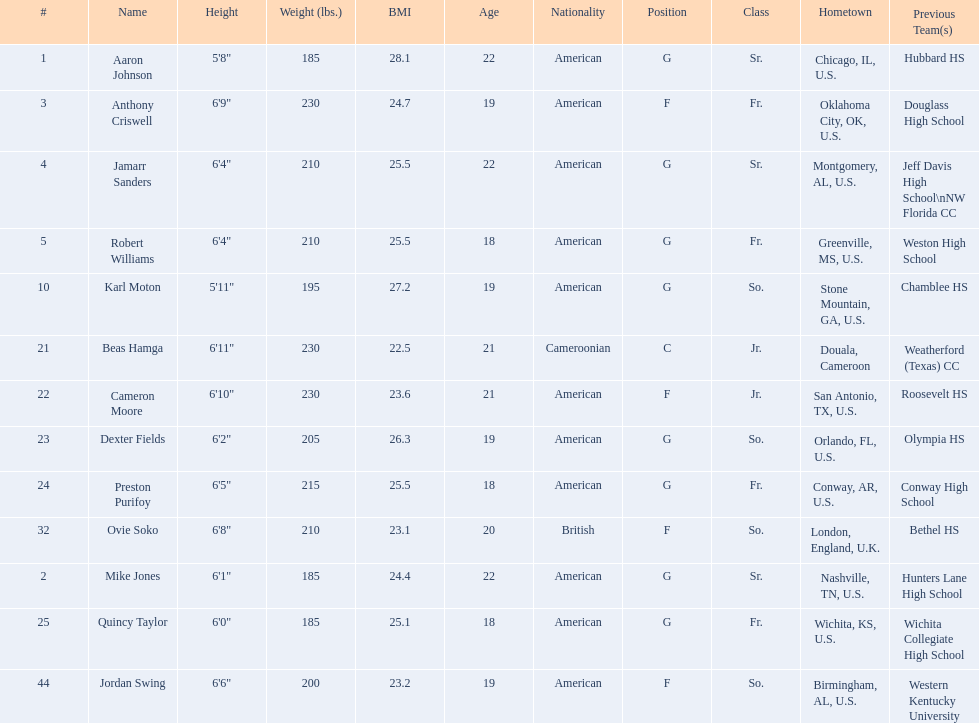Who is the tallest player on the team? Beas Hamga. 